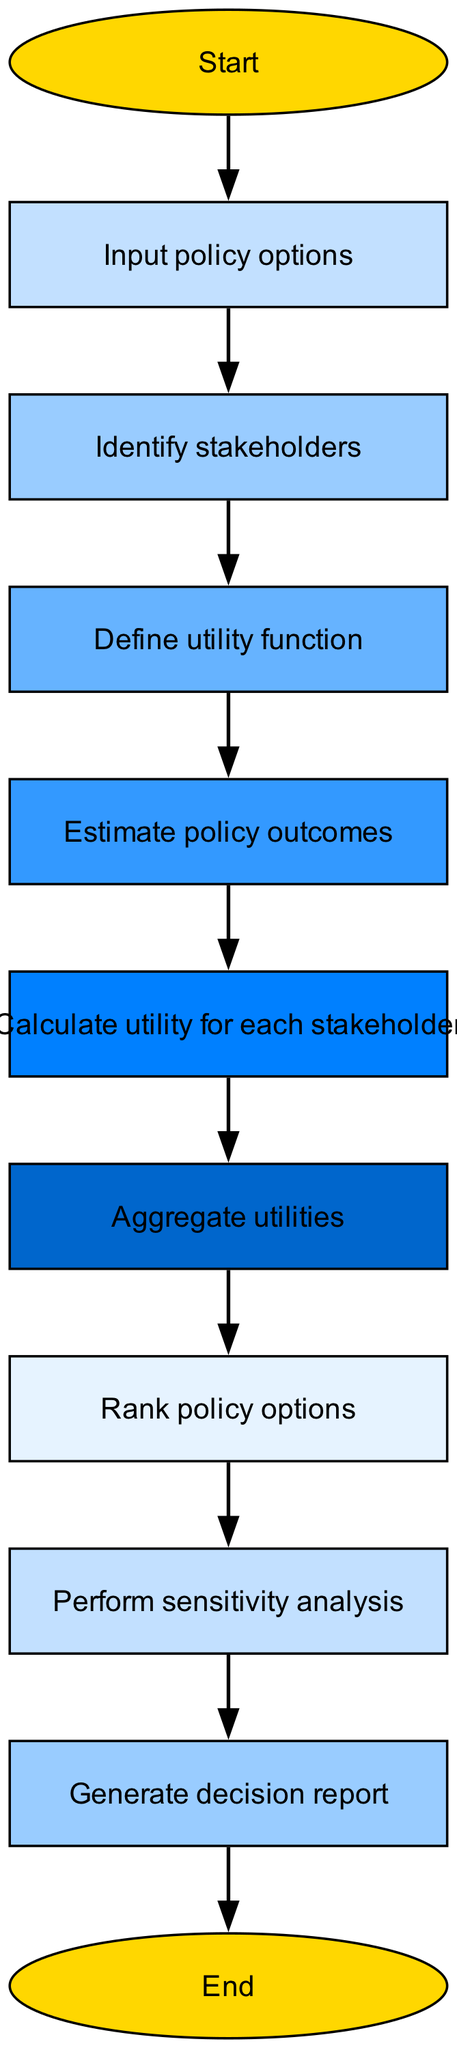What is the first step in the flowchart? The first step in the flowchart, starting from the "Start" node, is to "Input policy options". This is derived from the direct connection from "start" to "input".
Answer: Input policy options How many nodes are present in the diagram? By counting all the distinct nodes listed, there are a total of 11 nodes shown in the flowchart. This includes both the starting and ending nodes.
Answer: 11 What is the last step before ending the process? The last step before reaching the "end" node is "Generate decision report", following the directed edge from "report" to "end".
Answer: Generate decision report Which step involves stakeholder analysis? The step that specifically involves stakeholder analysis is "Identify stakeholders", as it is the node directly after "Input policy options" in the flowchart.
Answer: Identify stakeholders What action follows the estimation of policy outcomes? The action that follows the estimation of policy outcomes is "Calculate utility for each stakeholder", as indicated by the edge leading from "outcomes" to "calculate".
Answer: Calculate utility for each stakeholder What is the purpose of performing sensitivity analysis? Sensitivity analysis serves to test the robustness of the decision scores or utility values calculated earlier and ensures the decision-making process accounts for variability, making it essential for better policy analysis.
Answer: Analyze robustness Which node represents the aggregation of utility values? The node that represents the aggregation of utility values is "Aggregate utilities", which comes after calculating the individual utility scores for stakeholders.
Answer: Aggregate utilities How many edges connect the nodes in the flowchart? By counting the connections between nodes, there are a total of 10 edges connecting the various steps in the flowchart from start to end.
Answer: 10 What is the color of the "Calculate utility for each stakeholder" node? The "Calculate utility for each stakeholder" node is colored based on the provided color palette, and in the diagram, this specific node is colored with the blue shade.
Answer: Blue 